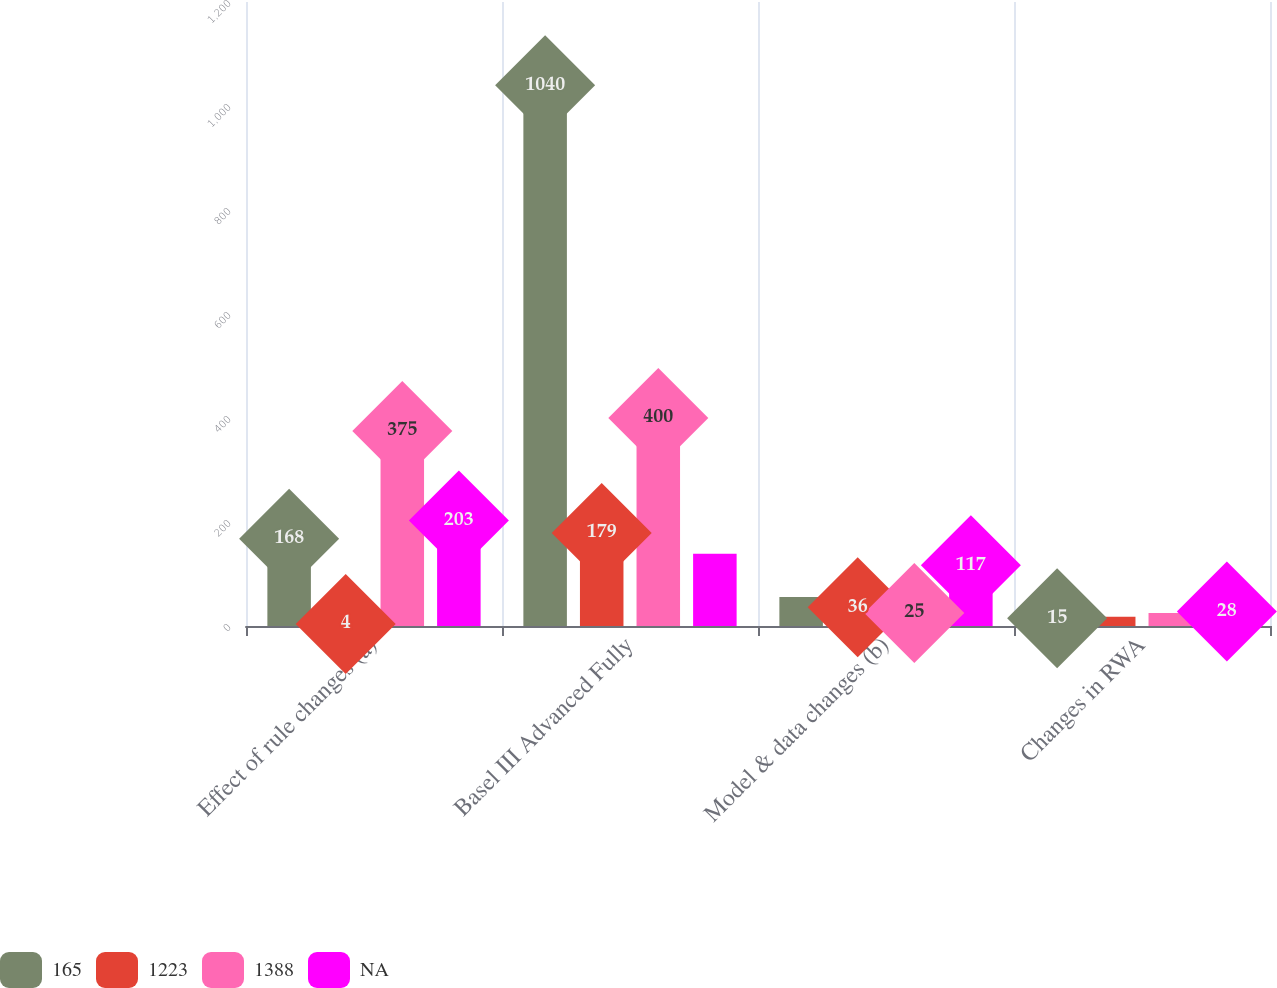Convert chart. <chart><loc_0><loc_0><loc_500><loc_500><stacked_bar_chart><ecel><fcel>Effect of rule changes (a)<fcel>Basel III Advanced Fully<fcel>Model & data changes (b)<fcel>Changes in RWA<nl><fcel>165<fcel>168<fcel>1040<fcel>56<fcel>15<nl><fcel>1223<fcel>4<fcel>179<fcel>36<fcel>18<nl><fcel>1388<fcel>375<fcel>400<fcel>25<fcel>25<nl><fcel>nan<fcel>203<fcel>139<fcel>117<fcel>28<nl></chart> 